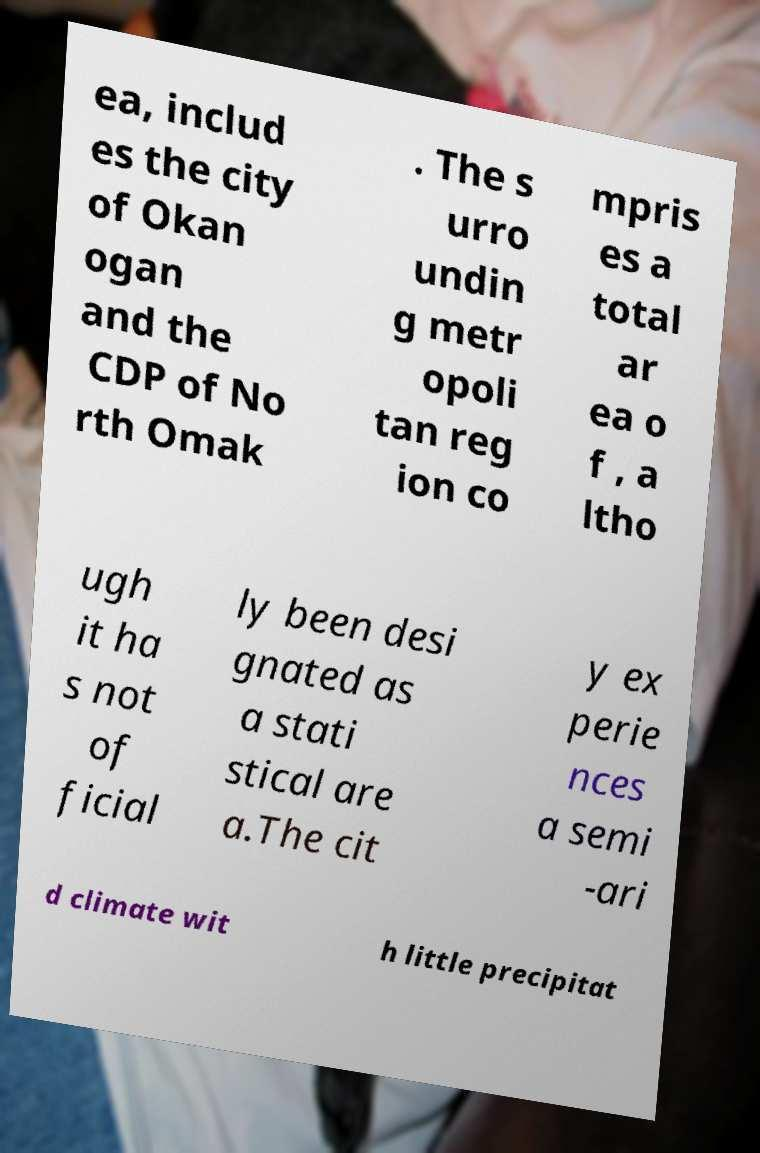I need the written content from this picture converted into text. Can you do that? ea, includ es the city of Okan ogan and the CDP of No rth Omak . The s urro undin g metr opoli tan reg ion co mpris es a total ar ea o f , a ltho ugh it ha s not of ficial ly been desi gnated as a stati stical are a.The cit y ex perie nces a semi -ari d climate wit h little precipitat 